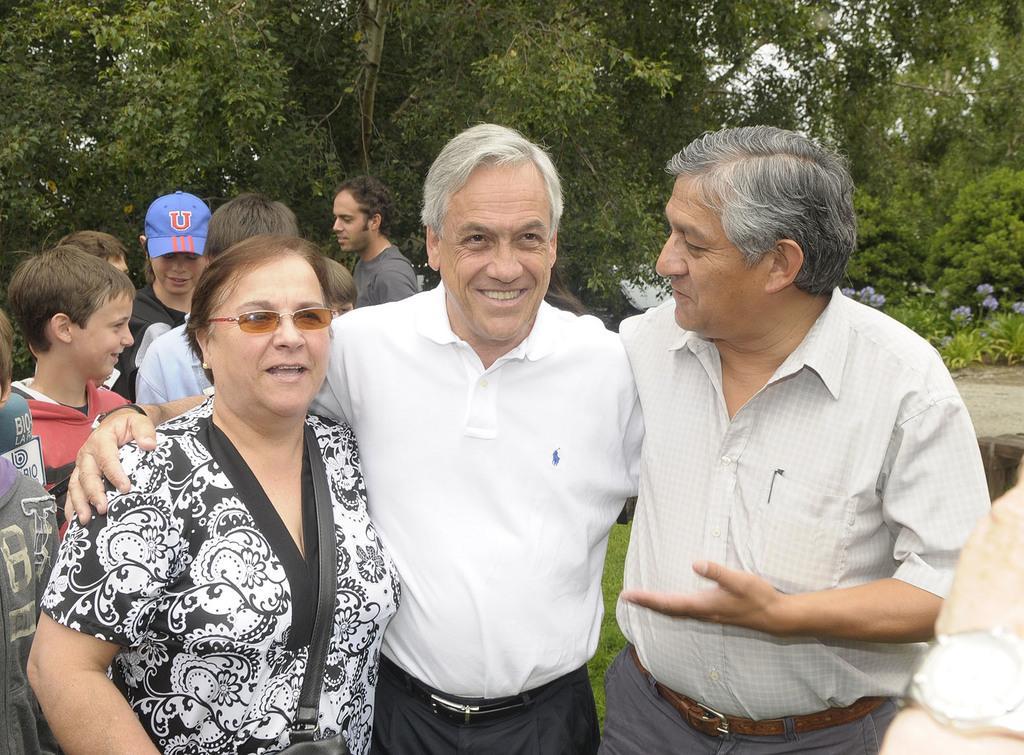How would you summarize this image in a sentence or two? In this image we can see many people. One lady is wearing cap. Another lady is wearing specs. In the back there are trees and plants with flowers. 